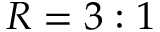<formula> <loc_0><loc_0><loc_500><loc_500>R = 3 \colon 1</formula> 